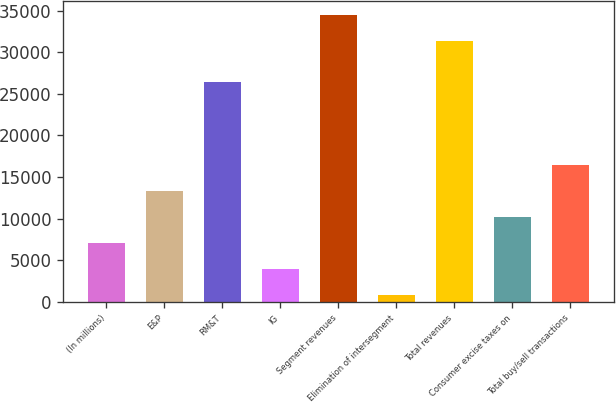Convert chart to OTSL. <chart><loc_0><loc_0><loc_500><loc_500><bar_chart><fcel>(In millions)<fcel>E&P<fcel>RM&T<fcel>IG<fcel>Segment revenues<fcel>Elimination of intersegment<fcel>Total revenues<fcel>Consumer excise taxes on<fcel>Total buy/sell transactions<nl><fcel>7057<fcel>13316<fcel>26399<fcel>3927.5<fcel>34424.5<fcel>798<fcel>31295<fcel>10186.5<fcel>16445.5<nl></chart> 